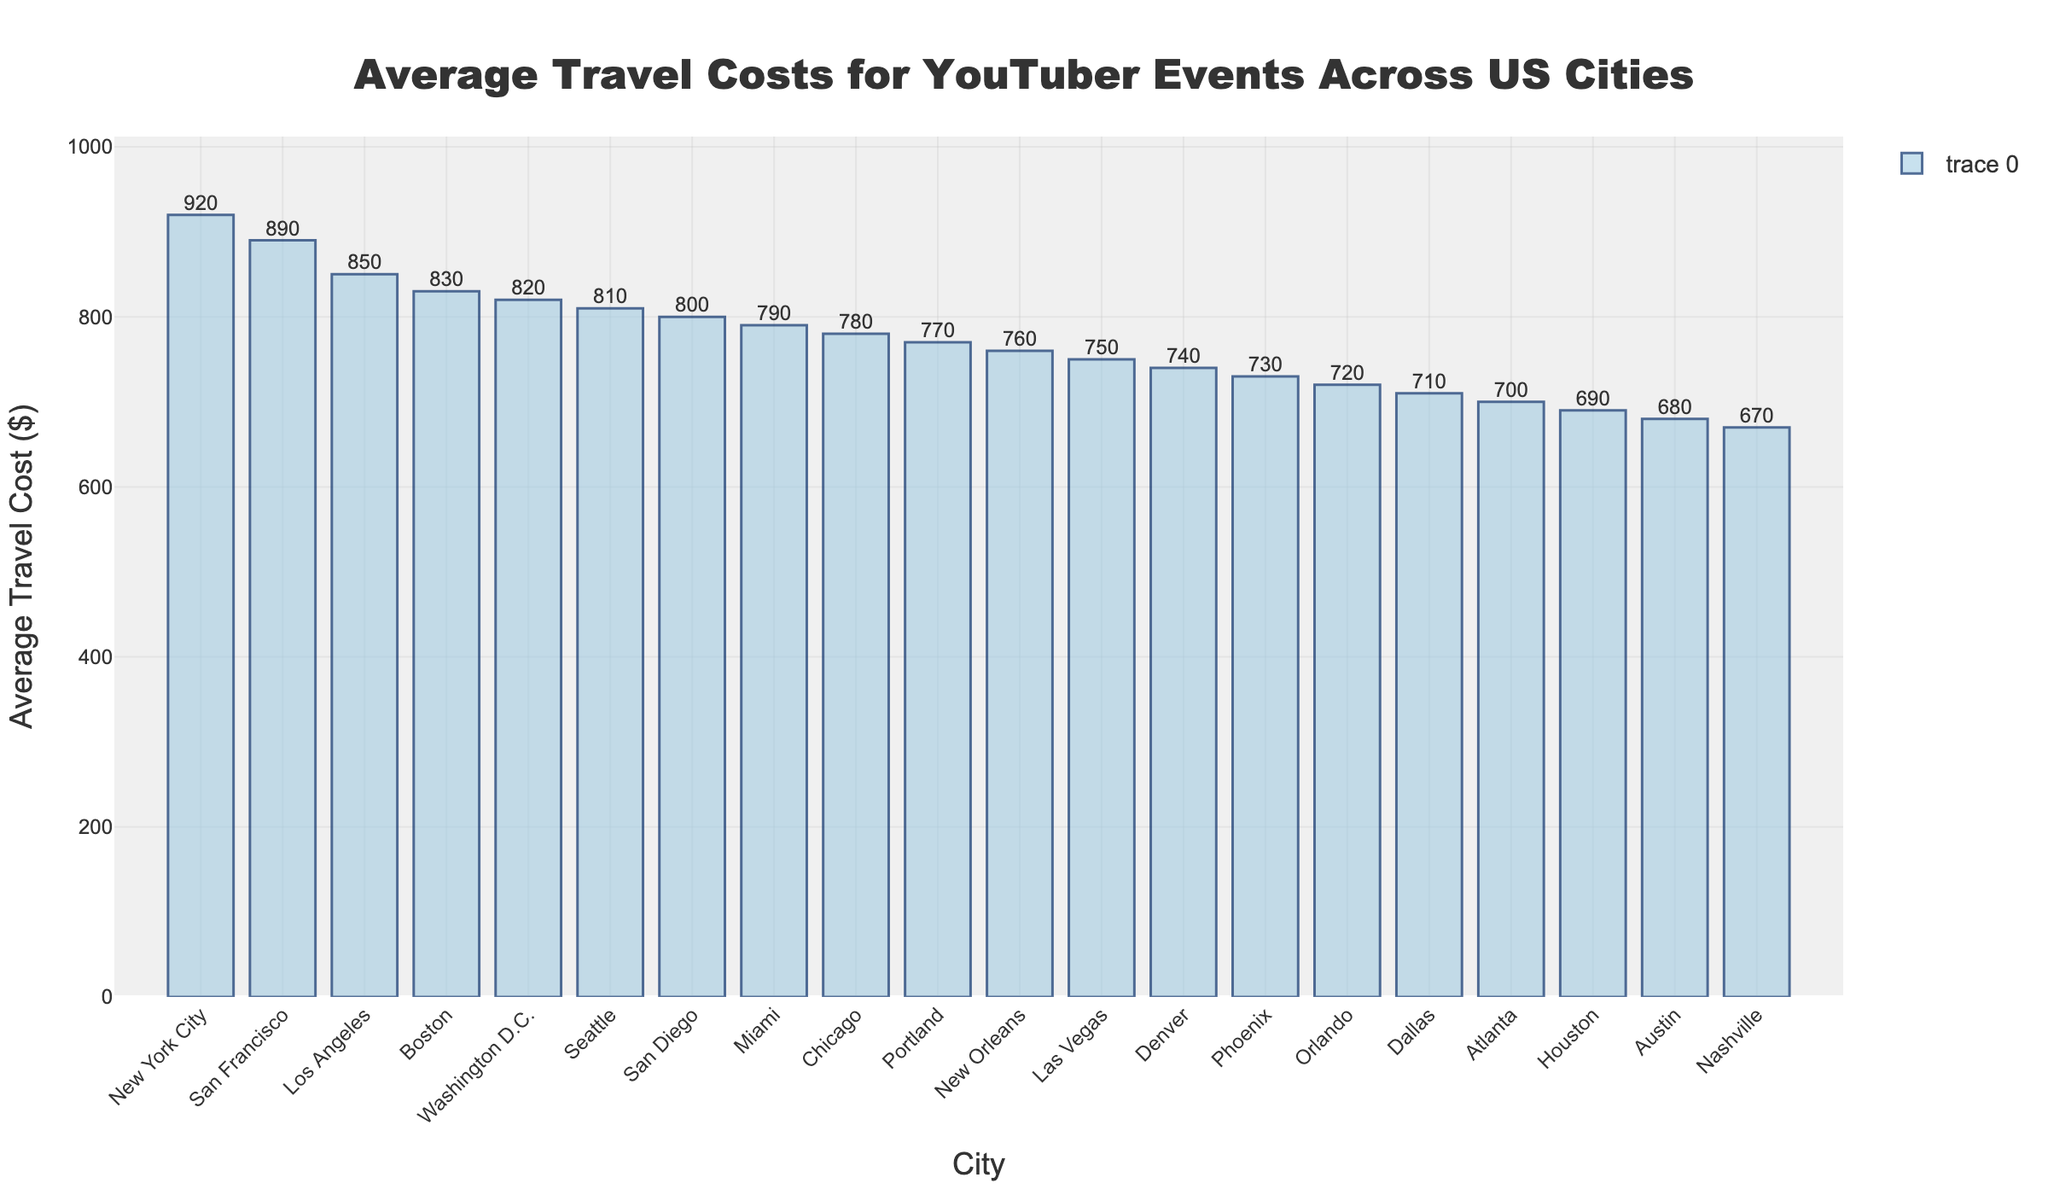What's the city with the highest average travel cost? To find the city with the highest average travel cost, look for the tallest bar in the chart. The highest bar represents New York City with an average travel cost of $920.
Answer: New York City How much more expensive is it to travel to San Francisco compared to Orlando? Find the average travel costs for San Francisco and Orlando from the chart. The average travel cost for San Francisco is $890 and for Orlando is $720. The difference can be calculated as $890 - $720 = $170.
Answer: $170 Which city has a lower travel cost, Denver or Phoenix? Compare the heights of the bars for Denver and Phoenix. The average travel cost for Denver is $740, whereas for Phoenix it is $730, which means Phoenix has a lower travel cost.
Answer: Phoenix What is the average travel cost for the three cities with the lowest travel costs? Identify the three cities with the shortest bars: Nashville ($670), Austin ($680), and Houston ($690). Calculate the average as:
(670 + 680 + 690) / 3 = 2040 / 3 = 680.
Answer: $680 How do the travel costs for Miami and Seattle compare? Look at the bars for Miami and Seattle. The average travel cost for Miami is $790, and for Seattle, it is $810. Therefore, Seattle has a slightly higher travel cost than Miami.
Answer: Seattle What is the difference in travel costs between Los Angeles and Boston? Locate the bars for Los Angeles ($850) and Boston ($830). The difference is calculated as $850 - $830 = $20.
Answer: $20 Which three cities have travel costs over $900? Identify the cities with travel costs over $900 by looking for bars taller than $900. Only New York City has a travel cost of $920.
Answer: New York City What is the median value of the travel costs? Arrange the travel costs in ascending order and find the middle value. Since there are 20 data points, the median is the average of the 10th and 11th values. These are Denver ($740) and Atlanta ($700). Calculating the average results in (740 + 700) / 2 = $720.
Answer: $720 